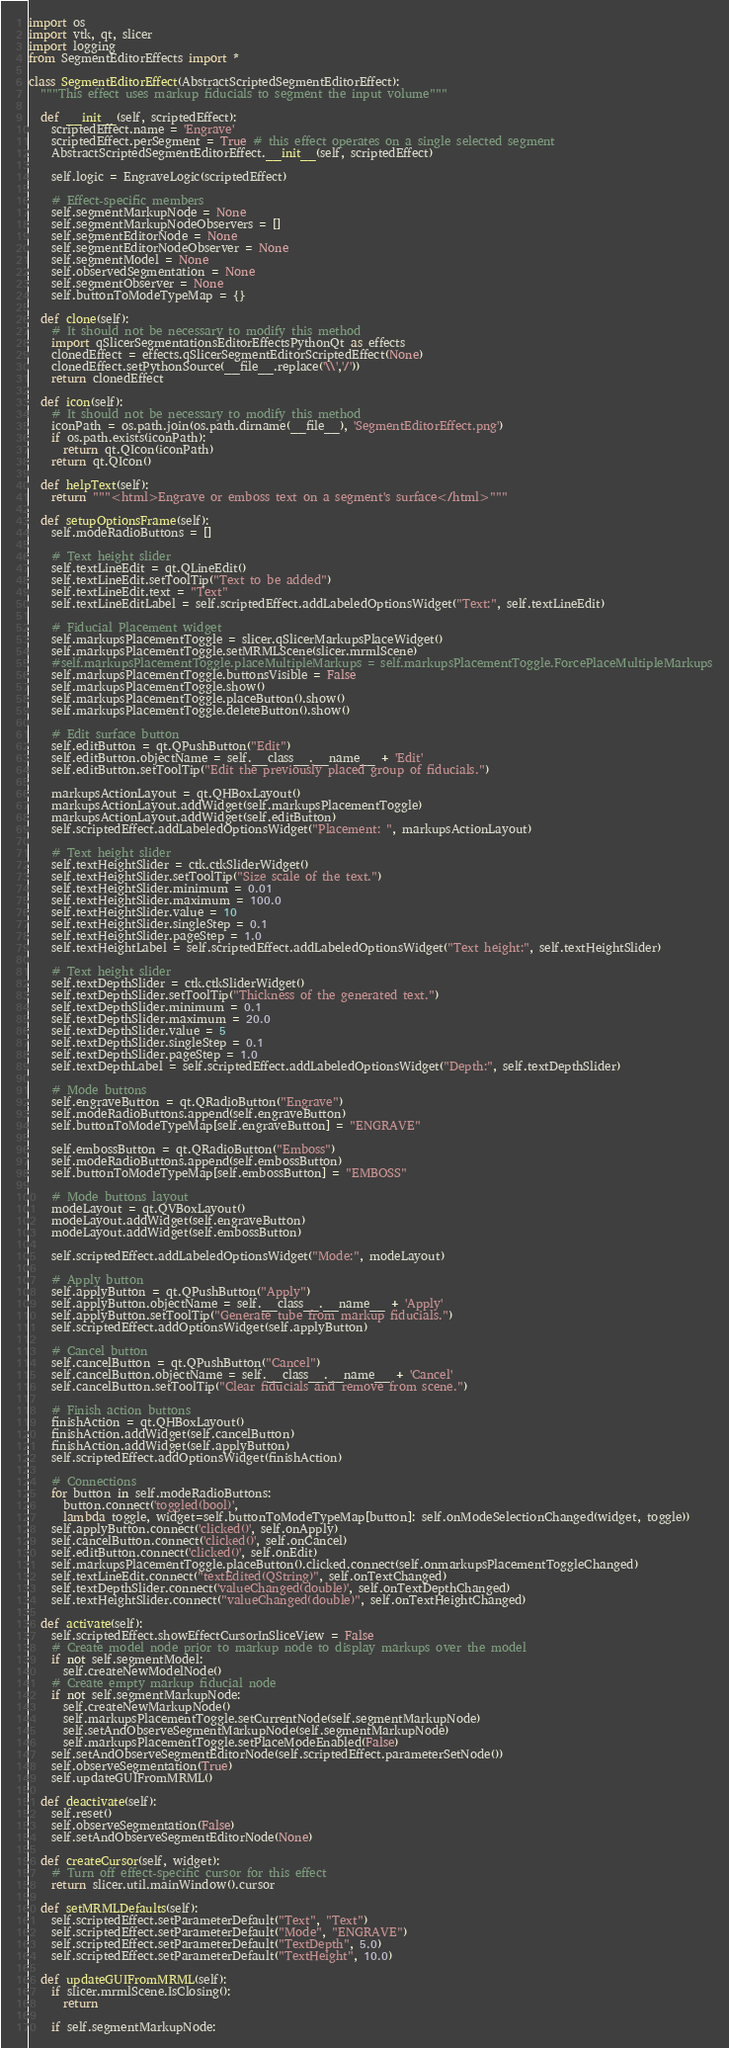<code> <loc_0><loc_0><loc_500><loc_500><_Python_>import os
import vtk, qt, slicer
import logging
from SegmentEditorEffects import *

class SegmentEditorEffect(AbstractScriptedSegmentEditorEffect):
  """This effect uses markup fiducials to segment the input volume"""

  def __init__(self, scriptedEffect):
    scriptedEffect.name = 'Engrave'
    scriptedEffect.perSegment = True # this effect operates on a single selected segment
    AbstractScriptedSegmentEditorEffect.__init__(self, scriptedEffect)

    self.logic = EngraveLogic(scriptedEffect)

    # Effect-specific members
    self.segmentMarkupNode = None
    self.segmentMarkupNodeObservers = []
    self.segmentEditorNode = None
    self.segmentEditorNodeObserver = None
    self.segmentModel = None
    self.observedSegmentation = None
    self.segmentObserver = None
    self.buttonToModeTypeMap = {}

  def clone(self):
    # It should not be necessary to modify this method
    import qSlicerSegmentationsEditorEffectsPythonQt as effects
    clonedEffect = effects.qSlicerSegmentEditorScriptedEffect(None)
    clonedEffect.setPythonSource(__file__.replace('\\','/'))
    return clonedEffect

  def icon(self):
    # It should not be necessary to modify this method
    iconPath = os.path.join(os.path.dirname(__file__), 'SegmentEditorEffect.png')
    if os.path.exists(iconPath):
      return qt.QIcon(iconPath)
    return qt.QIcon()

  def helpText(self):
    return """<html>Engrave or emboss text on a segment's surface</html>"""

  def setupOptionsFrame(self):
    self.modeRadioButtons = []

    # Text height slider
    self.textLineEdit = qt.QLineEdit()
    self.textLineEdit.setToolTip("Text to be added")
    self.textLineEdit.text = "Text"
    self.textLineEditLabel = self.scriptedEffect.addLabeledOptionsWidget("Text:", self.textLineEdit)

    # Fiducial Placement widget
    self.markupsPlacementToggle = slicer.qSlicerMarkupsPlaceWidget()
    self.markupsPlacementToggle.setMRMLScene(slicer.mrmlScene)
    #self.markupsPlacementToggle.placeMultipleMarkups = self.markupsPlacementToggle.ForcePlaceMultipleMarkups
    self.markupsPlacementToggle.buttonsVisible = False
    self.markupsPlacementToggle.show()
    self.markupsPlacementToggle.placeButton().show()
    self.markupsPlacementToggle.deleteButton().show()

    # Edit surface button
    self.editButton = qt.QPushButton("Edit")
    self.editButton.objectName = self.__class__.__name__ + 'Edit'
    self.editButton.setToolTip("Edit the previously placed group of fiducials.")

    markupsActionLayout = qt.QHBoxLayout()
    markupsActionLayout.addWidget(self.markupsPlacementToggle)
    markupsActionLayout.addWidget(self.editButton)
    self.scriptedEffect.addLabeledOptionsWidget("Placement: ", markupsActionLayout)

    # Text height slider
    self.textHeightSlider = ctk.ctkSliderWidget()
    self.textHeightSlider.setToolTip("Size scale of the text.")
    self.textHeightSlider.minimum = 0.01
    self.textHeightSlider.maximum = 100.0
    self.textHeightSlider.value = 10
    self.textHeightSlider.singleStep = 0.1
    self.textHeightSlider.pageStep = 1.0
    self.textHeightLabel = self.scriptedEffect.addLabeledOptionsWidget("Text height:", self.textHeightSlider) 

    # Text height slider
    self.textDepthSlider = ctk.ctkSliderWidget()
    self.textDepthSlider.setToolTip("Thickness of the generated text.")
    self.textDepthSlider.minimum = 0.1
    self.textDepthSlider.maximum = 20.0
    self.textDepthSlider.value = 5
    self.textDepthSlider.singleStep = 0.1
    self.textDepthSlider.pageStep = 1.0
    self.textDepthLabel = self.scriptedEffect.addLabeledOptionsWidget("Depth:", self.textDepthSlider) 

    # Mode buttons
    self.engraveButton = qt.QRadioButton("Engrave")
    self.modeRadioButtons.append(self.engraveButton)
    self.buttonToModeTypeMap[self.engraveButton] = "ENGRAVE"

    self.embossButton = qt.QRadioButton("Emboss")
    self.modeRadioButtons.append(self.embossButton)
    self.buttonToModeTypeMap[self.embossButton] = "EMBOSS"

    # Mode buttons layout
    modeLayout = qt.QVBoxLayout()
    modeLayout.addWidget(self.engraveButton)
    modeLayout.addWidget(self.embossButton)

    self.scriptedEffect.addLabeledOptionsWidget("Mode:", modeLayout)

    # Apply button
    self.applyButton = qt.QPushButton("Apply")
    self.applyButton.objectName = self.__class__.__name__ + 'Apply'
    self.applyButton.setToolTip("Generate tube from markup fiducials.")
    self.scriptedEffect.addOptionsWidget(self.applyButton)

    # Cancel button
    self.cancelButton = qt.QPushButton("Cancel")
    self.cancelButton.objectName = self.__class__.__name__ + 'Cancel'
    self.cancelButton.setToolTip("Clear fiducials and remove from scene.")

    # Finish action buttons
    finishAction = qt.QHBoxLayout()
    finishAction.addWidget(self.cancelButton)
    finishAction.addWidget(self.applyButton)
    self.scriptedEffect.addOptionsWidget(finishAction)

    # Connections
    for button in self.modeRadioButtons:
      button.connect('toggled(bool)',
      lambda toggle, widget=self.buttonToModeTypeMap[button]: self.onModeSelectionChanged(widget, toggle))
    self.applyButton.connect('clicked()', self.onApply)
    self.cancelButton.connect('clicked()', self.onCancel)
    self.editButton.connect('clicked()', self.onEdit)
    self.markupsPlacementToggle.placeButton().clicked.connect(self.onmarkupsPlacementToggleChanged)
    self.textLineEdit.connect("textEdited(QString)", self.onTextChanged)
    self.textDepthSlider.connect('valueChanged(double)', self.onTextDepthChanged)
    self.textHeightSlider.connect("valueChanged(double)", self.onTextHeightChanged)

  def activate(self):
    self.scriptedEffect.showEffectCursorInSliceView = False
    # Create model node prior to markup node to display markups over the model
    if not self.segmentModel:
      self.createNewModelNode()
    # Create empty markup fiducial node
    if not self.segmentMarkupNode:
      self.createNewMarkupNode()
      self.markupsPlacementToggle.setCurrentNode(self.segmentMarkupNode)
      self.setAndObserveSegmentMarkupNode(self.segmentMarkupNode)
      self.markupsPlacementToggle.setPlaceModeEnabled(False)
    self.setAndObserveSegmentEditorNode(self.scriptedEffect.parameterSetNode())
    self.observeSegmentation(True)
    self.updateGUIFromMRML()

  def deactivate(self):
    self.reset()
    self.observeSegmentation(False)
    self.setAndObserveSegmentEditorNode(None)

  def createCursor(self, widget):
    # Turn off effect-specific cursor for this effect
    return slicer.util.mainWindow().cursor

  def setMRMLDefaults(self):
    self.scriptedEffect.setParameterDefault("Text", "Text")
    self.scriptedEffect.setParameterDefault("Mode", "ENGRAVE")
    self.scriptedEffect.setParameterDefault("TextDepth", 5.0)
    self.scriptedEffect.setParameterDefault("TextHeight", 10.0) 

  def updateGUIFromMRML(self):
    if slicer.mrmlScene.IsClosing():
      return

    if self.segmentMarkupNode:</code> 